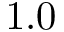<formula> <loc_0><loc_0><loc_500><loc_500>1 . 0</formula> 